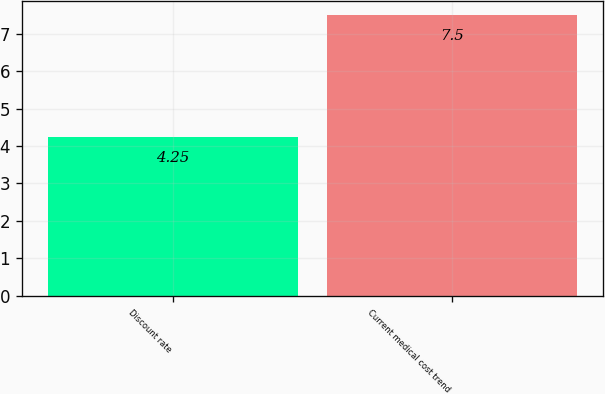Convert chart to OTSL. <chart><loc_0><loc_0><loc_500><loc_500><bar_chart><fcel>Discount rate<fcel>Current medical cost trend<nl><fcel>4.25<fcel>7.5<nl></chart> 